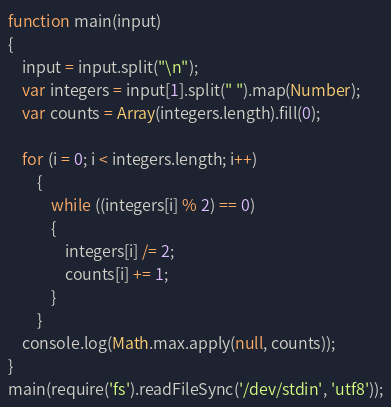<code> <loc_0><loc_0><loc_500><loc_500><_JavaScript_>function main(input) 
{
    input = input.split("\n");
    var integers = input[1].split(" ").map(Number);
    var counts = Array(integers.length).fill(0);

    for (i = 0; i < integers.length; i++)
        {
            while ((integers[i] % 2) == 0)
            {
                integers[i] /= 2;
                counts[i] += 1;
            }
        }
    console.log(Math.max.apply(null, counts));
}
main(require('fs').readFileSync('/dev/stdin', 'utf8'));</code> 